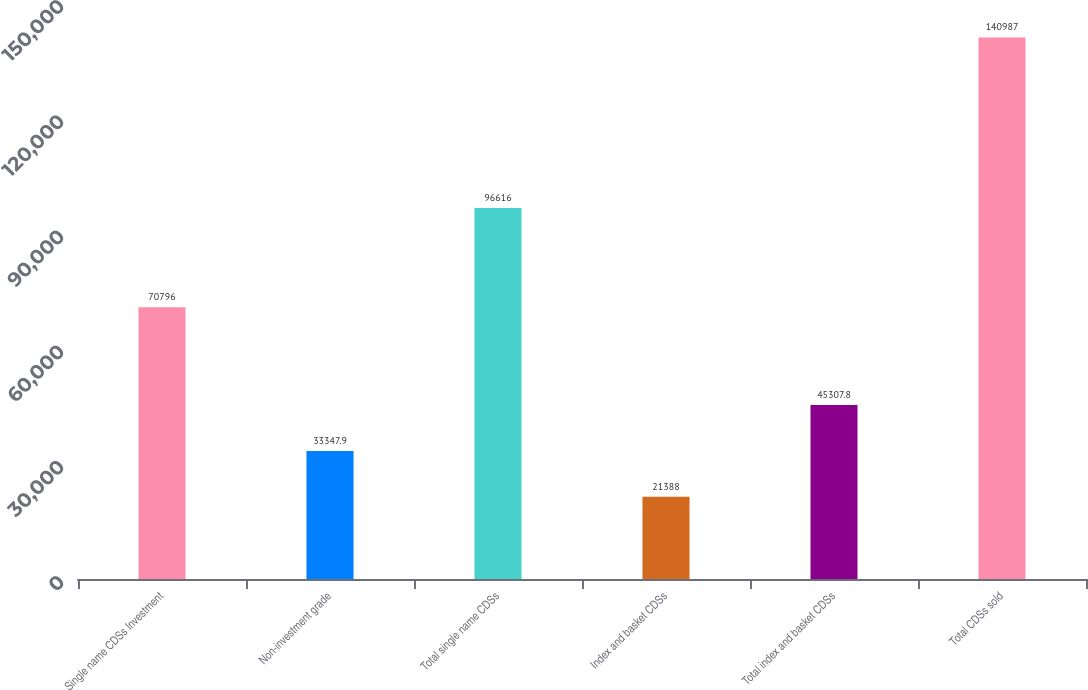Convert chart to OTSL. <chart><loc_0><loc_0><loc_500><loc_500><bar_chart><fcel>Single name CDSs Investment<fcel>Non-investment grade<fcel>Total single name CDSs<fcel>Index and basket CDSs<fcel>Total index and basket CDSs<fcel>Total CDSs sold<nl><fcel>70796<fcel>33347.9<fcel>96616<fcel>21388<fcel>45307.8<fcel>140987<nl></chart> 